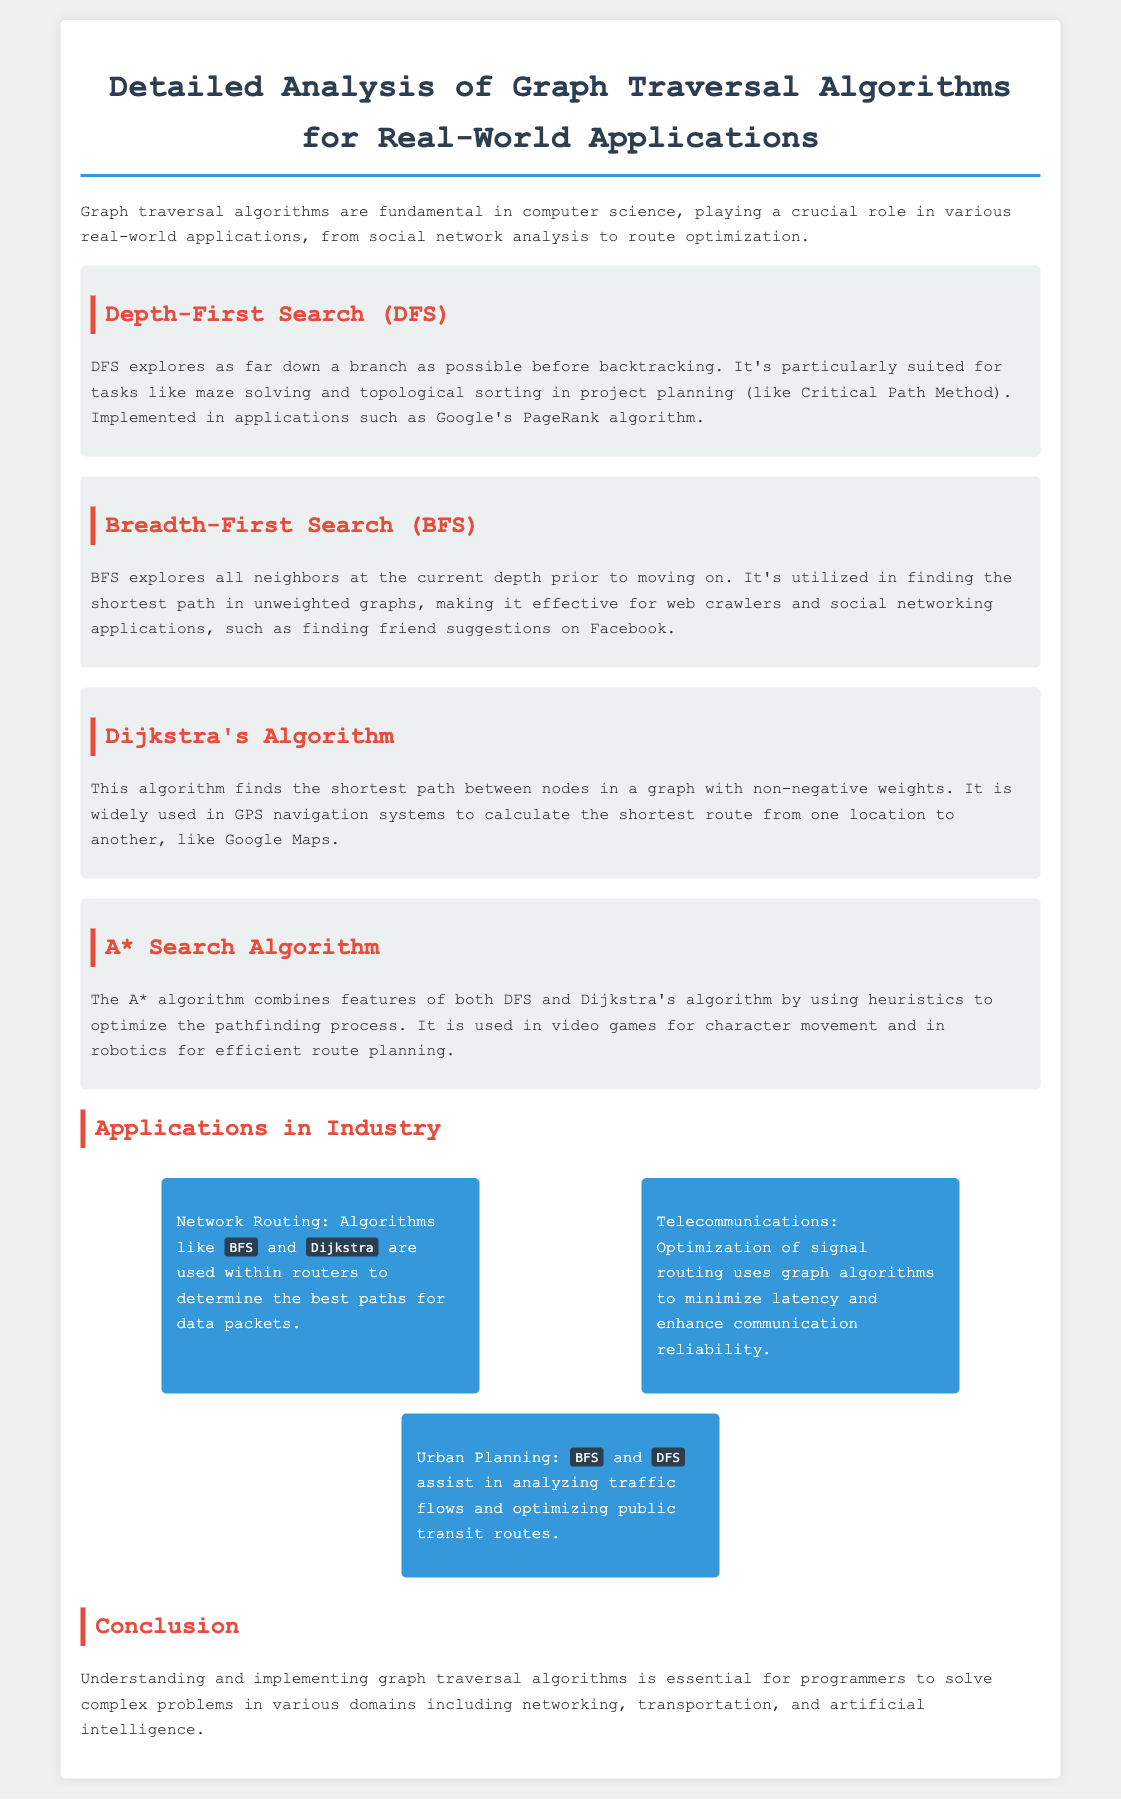What is the title of the document? The title of the document is stated at the top of the rendered content.
Answer: Detailed Analysis of Graph Traversal Algorithms for Real-World Applications What algorithm is particularly suited for maze solving? The document specifies that DFS is particularly suited for tasks like maze solving.
Answer: Depth-First Search In which applications is BFS used for finding friend suggestions? The document illustrates that BFS is utilized in social networking applications, specifically for finding friend suggestions on Facebook.
Answer: Facebook What is the primary function of Dijkstra's Algorithm? The document describes Dijkstra's Algorithm as finding the shortest path between nodes in a graph with non-negative weights.
Answer: Shortest path Which algorithm combines features of DFS and Dijkstra's algorithm? The document mentions that the A* algorithm combines features of both DFS and Dijkstra's algorithm.
Answer: A* Search Algorithm What industry applies BFS and DFS to optimize public transit routes? The document indicates that urban planning utilizes BFS and DFS for this purpose.
Answer: Urban Planning 